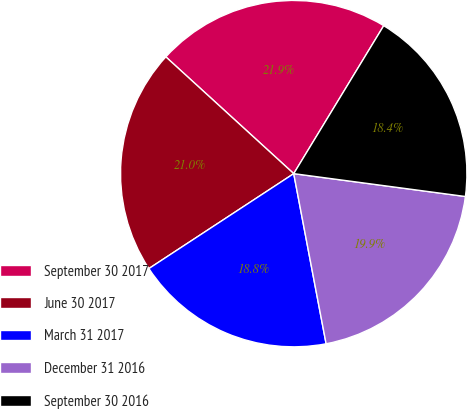<chart> <loc_0><loc_0><loc_500><loc_500><pie_chart><fcel>September 30 2017<fcel>June 30 2017<fcel>March 31 2017<fcel>December 31 2016<fcel>September 30 2016<nl><fcel>21.92%<fcel>21.01%<fcel>18.76%<fcel>19.9%<fcel>18.41%<nl></chart> 